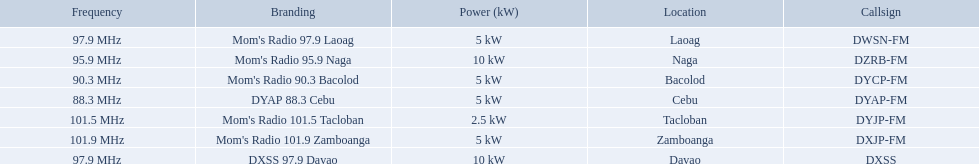What brandings have a power of 5 kw? Mom's Radio 97.9 Laoag, Mom's Radio 90.3 Bacolod, DYAP 88.3 Cebu, Mom's Radio 101.9 Zamboanga. Which of these has a call-sign beginning with dy? Mom's Radio 90.3 Bacolod, DYAP 88.3 Cebu. Which of those uses the lowest frequency? DYAP 88.3 Cebu. What are all of the frequencies? 97.9 MHz, 95.9 MHz, 90.3 MHz, 88.3 MHz, 101.5 MHz, 101.9 MHz, 97.9 MHz. Which of these frequencies is the lowest? 88.3 MHz. Which branding does this frequency belong to? DYAP 88.3 Cebu. 